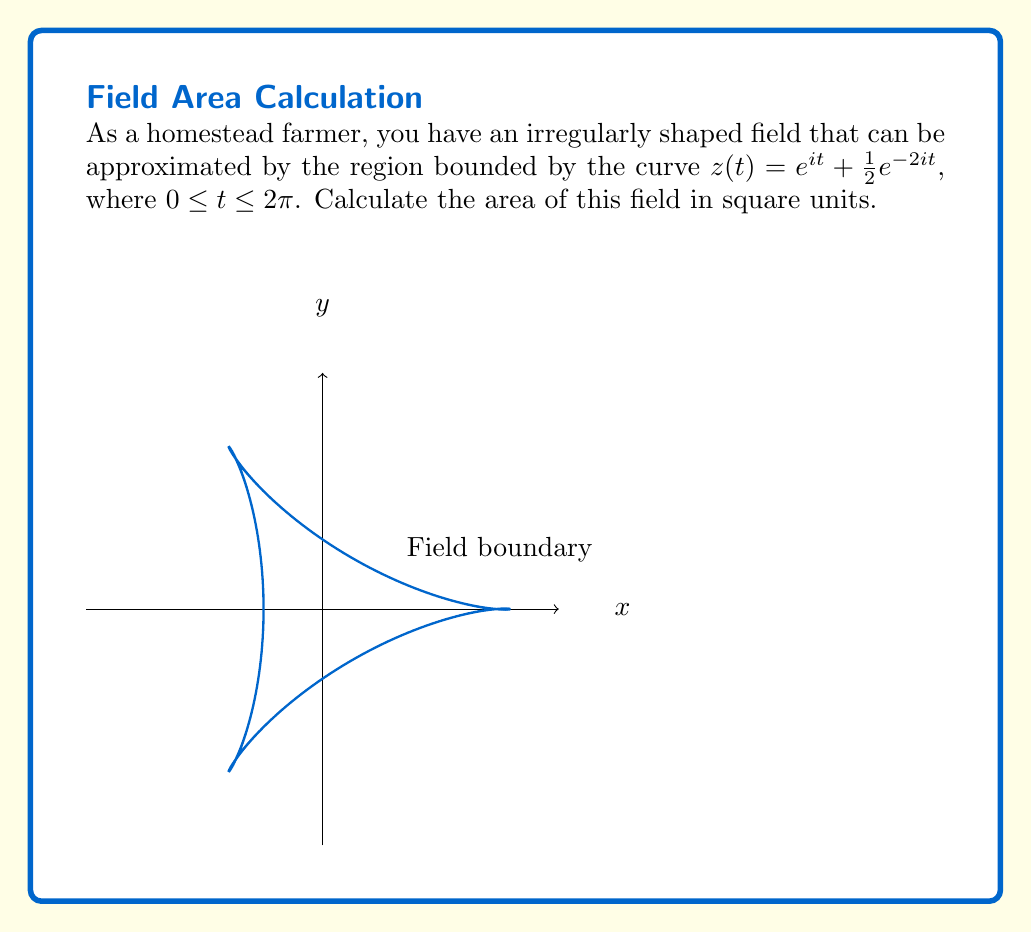Can you solve this math problem? To calculate the area of this irregularly shaped field, we can use Green's theorem in the complex plane. The area enclosed by a simple closed curve $C$ given by $z(t) = x(t) + iy(t)$, where $t$ goes from $a$ to $b$, is:

$$A = -\frac{1}{2}i\oint_C z d\bar{z} = \frac{1}{2}\int_a^b [x(t)y'(t) - y(t)x'(t)] dt$$

For our curve $z(t) = e^{it} + \frac{1}{2}e^{-2it}$, we have:

$$z(t) = (\cos t + \frac{1}{2}\cos 2t) + i(\sin t - \frac{1}{2}\sin 2t)$$

So, $x(t) = \cos t + \frac{1}{2}\cos 2t$ and $y(t) = \sin t - \frac{1}{2}\sin 2t$

Differentiating:
$$x'(t) = -\sin t - \sin 2t$$
$$y'(t) = \cos t - \cos 2t$$

Substituting into the area formula:

$$\begin{align*}
A &= \frac{1}{2}\int_0^{2\pi} [(\cos t + \frac{1}{2}\cos 2t)(\cos t - \cos 2t) - (\sin t - \frac{1}{2}\sin 2t)(-\sin t - \sin 2t)] dt \\
&= \frac{1}{2}\int_0^{2\pi} [\cos^2 t - \cos t \cos 2t + \frac{1}{2}\cos 2t \cos t - \frac{1}{2}\cos^2 2t + \sin^2 t + \sin t \sin 2t - \frac{1}{2}\sin 2t \sin t - \frac{1}{2}\sin^2 2t] dt
\end{align*}$$

Using trigonometric identities and simplifying:

$$\begin{align*}
A &= \frac{1}{2}\int_0^{2\pi} [1 - \frac{1}{2}\cos 2t + \frac{1}{2}\cos 2t - \frac{1}{4}(1 + \cos 4t)] dt \\
&= \frac{1}{2}\int_0^{2\pi} [\frac{3}{4} - \frac{1}{4}\cos 4t] dt \\
&= \frac{1}{2}[\frac{3}{4}t - \frac{1}{16}\sin 4t]_0^{2\pi} \\
&= \frac{1}{2}[\frac{3}{4}(2\pi) - 0] \\
&= \frac{3\pi}{4}
\end{align*}$$
Answer: $\frac{3\pi}{4}$ square units 